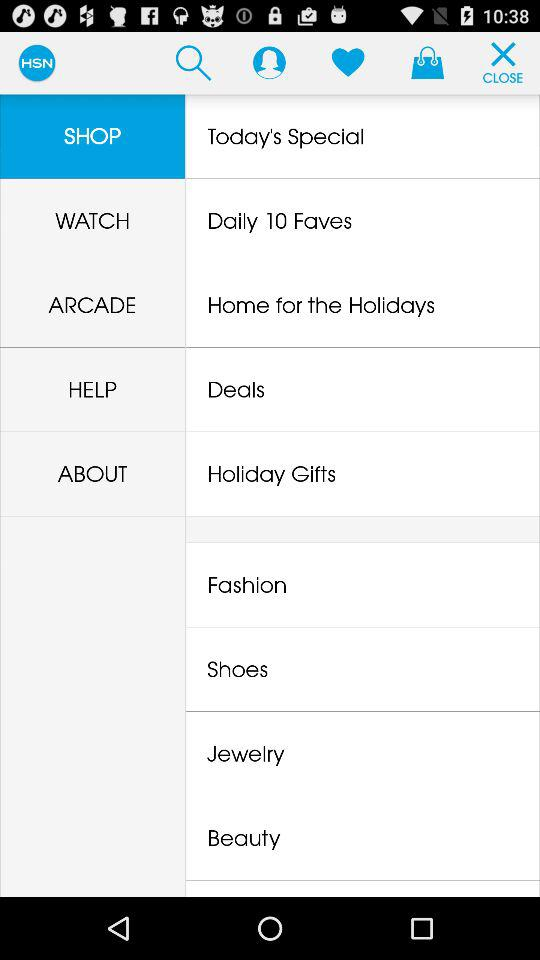Which item is selected? The selected item is "SHOP". 